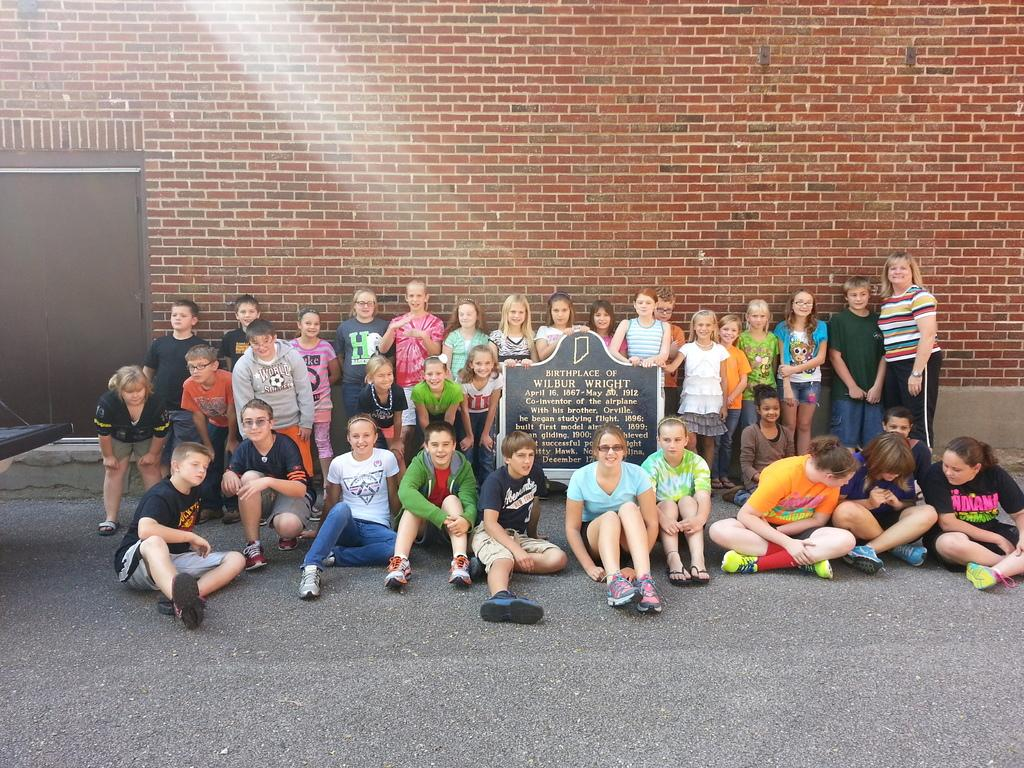What is located in the center of the image? There are kids and women in the center of the image, along with a board. What is the object on the left side of the image? Unfortunately, the provided facts do not specify the object on the left side of the image. What can be seen at the bottom of the image? There is a road at the bottom of the image. What is present at the top of the image? There is a brick wall at the top of the image. Are there any waves visible in the image? No, there are no waves present in the image. In which direction are the kids and women facing in the image? The provided facts do not specify the direction the kids and women are facing in the image. 